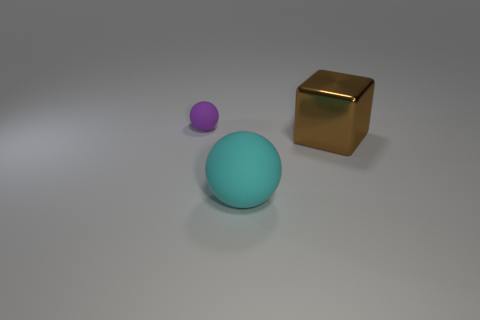Subtract all spheres. How many objects are left? 1 Add 3 tiny brown metal blocks. How many objects exist? 6 Subtract all cyan spheres. Subtract all yellow cylinders. How many spheres are left? 1 Subtract all green balls. How many cyan blocks are left? 0 Subtract all big metallic objects. Subtract all matte things. How many objects are left? 0 Add 2 large blocks. How many large blocks are left? 3 Add 2 cyan metallic cylinders. How many cyan metallic cylinders exist? 2 Subtract 0 yellow cubes. How many objects are left? 3 